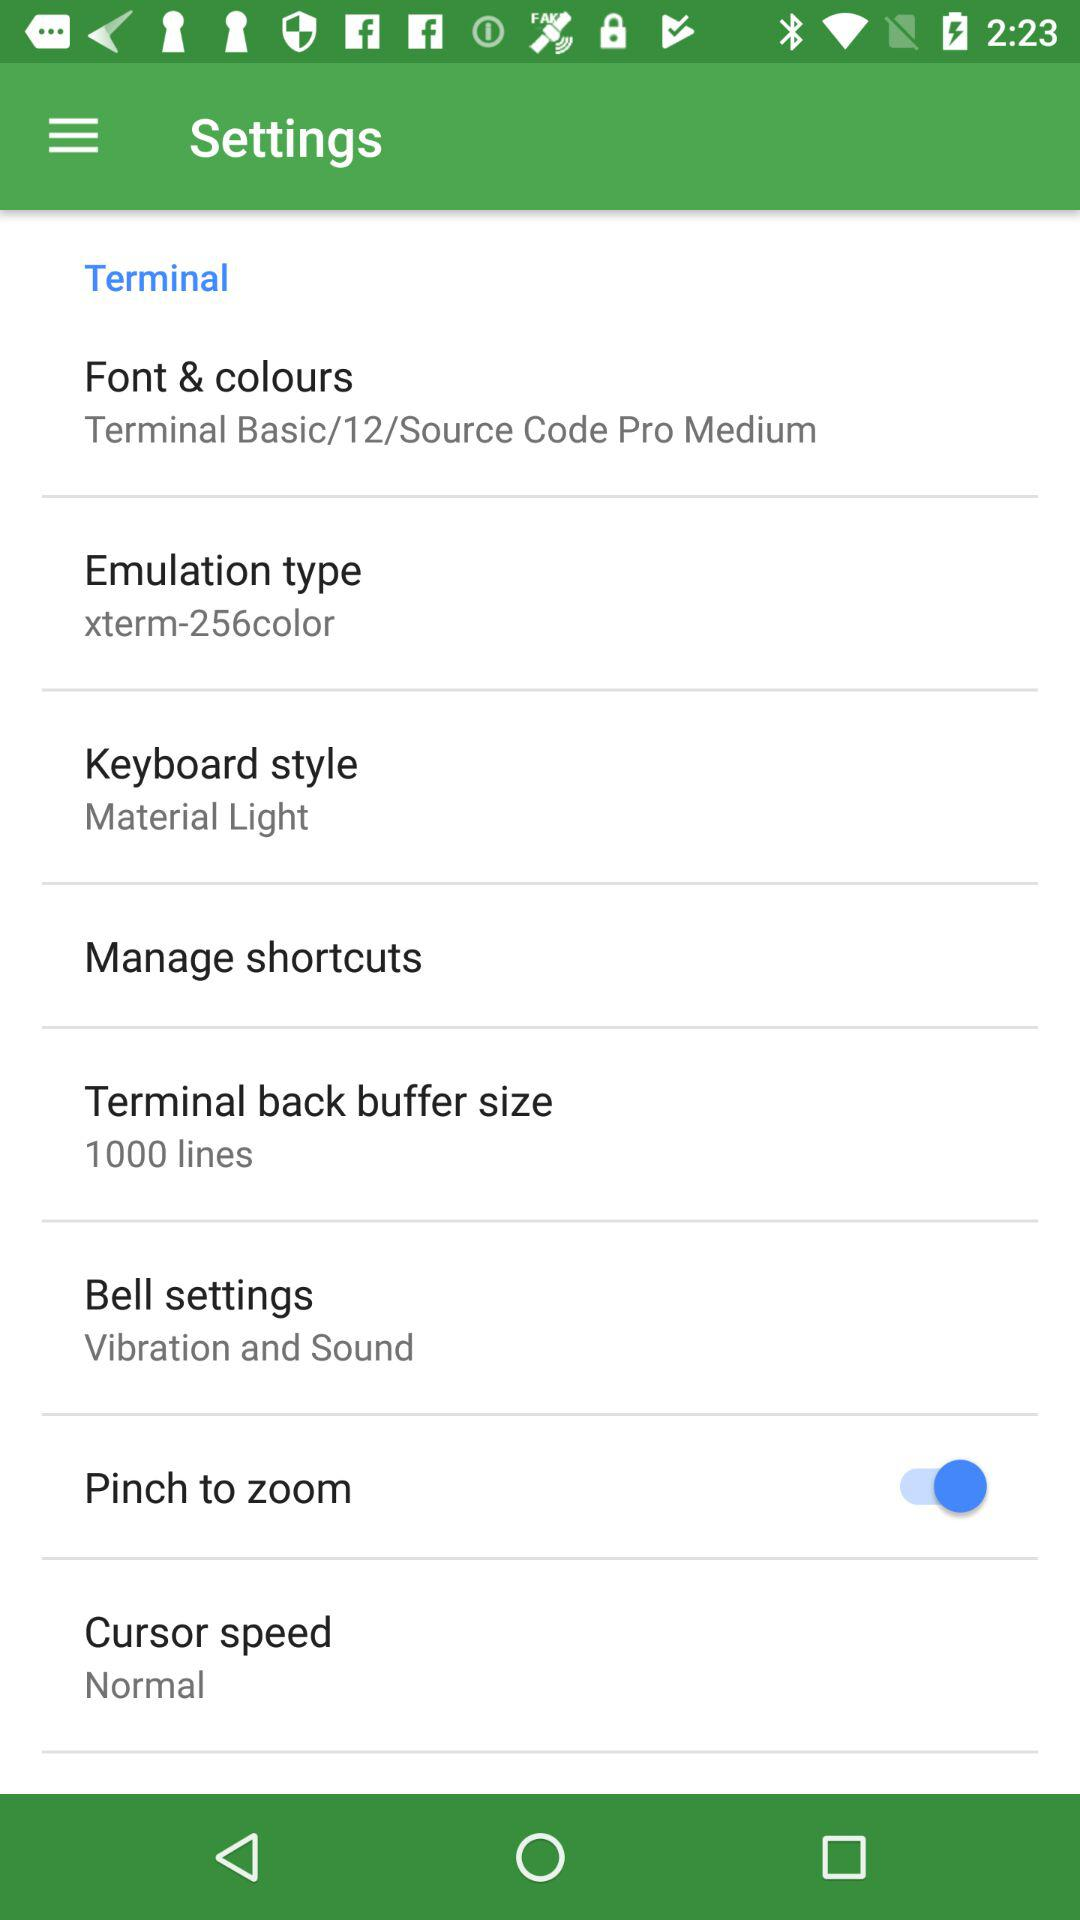What are the bell settings? The bell settings are "Vibration and Sound". 